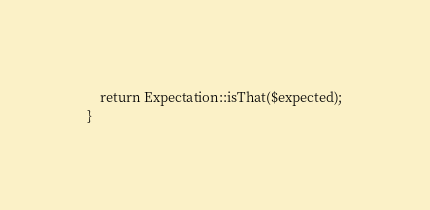<code> <loc_0><loc_0><loc_500><loc_500><_PHP_>    return Expectation::isThat($expected);
}
</code> 